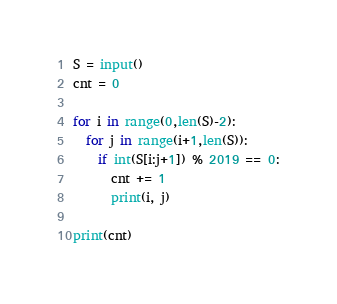Convert code to text. <code><loc_0><loc_0><loc_500><loc_500><_Python_>S = input()
cnt = 0

for i in range(0,len(S)-2):
  for j in range(i+1,len(S)):
    if int(S[i:j+1]) % 2019 == 0:
      cnt += 1
      print(i, j)
      
print(cnt)</code> 